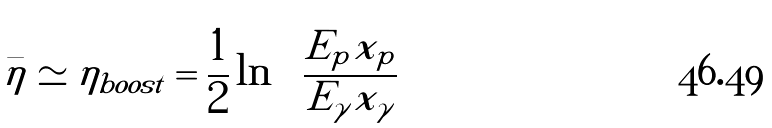<formula> <loc_0><loc_0><loc_500><loc_500>\bar { \eta } \simeq \eta _ { b o o s t } = \frac { 1 } { 2 } \ln \left ( \frac { E _ { p } x _ { p } } { E _ { \gamma } x _ { \gamma } } \right )</formula> 